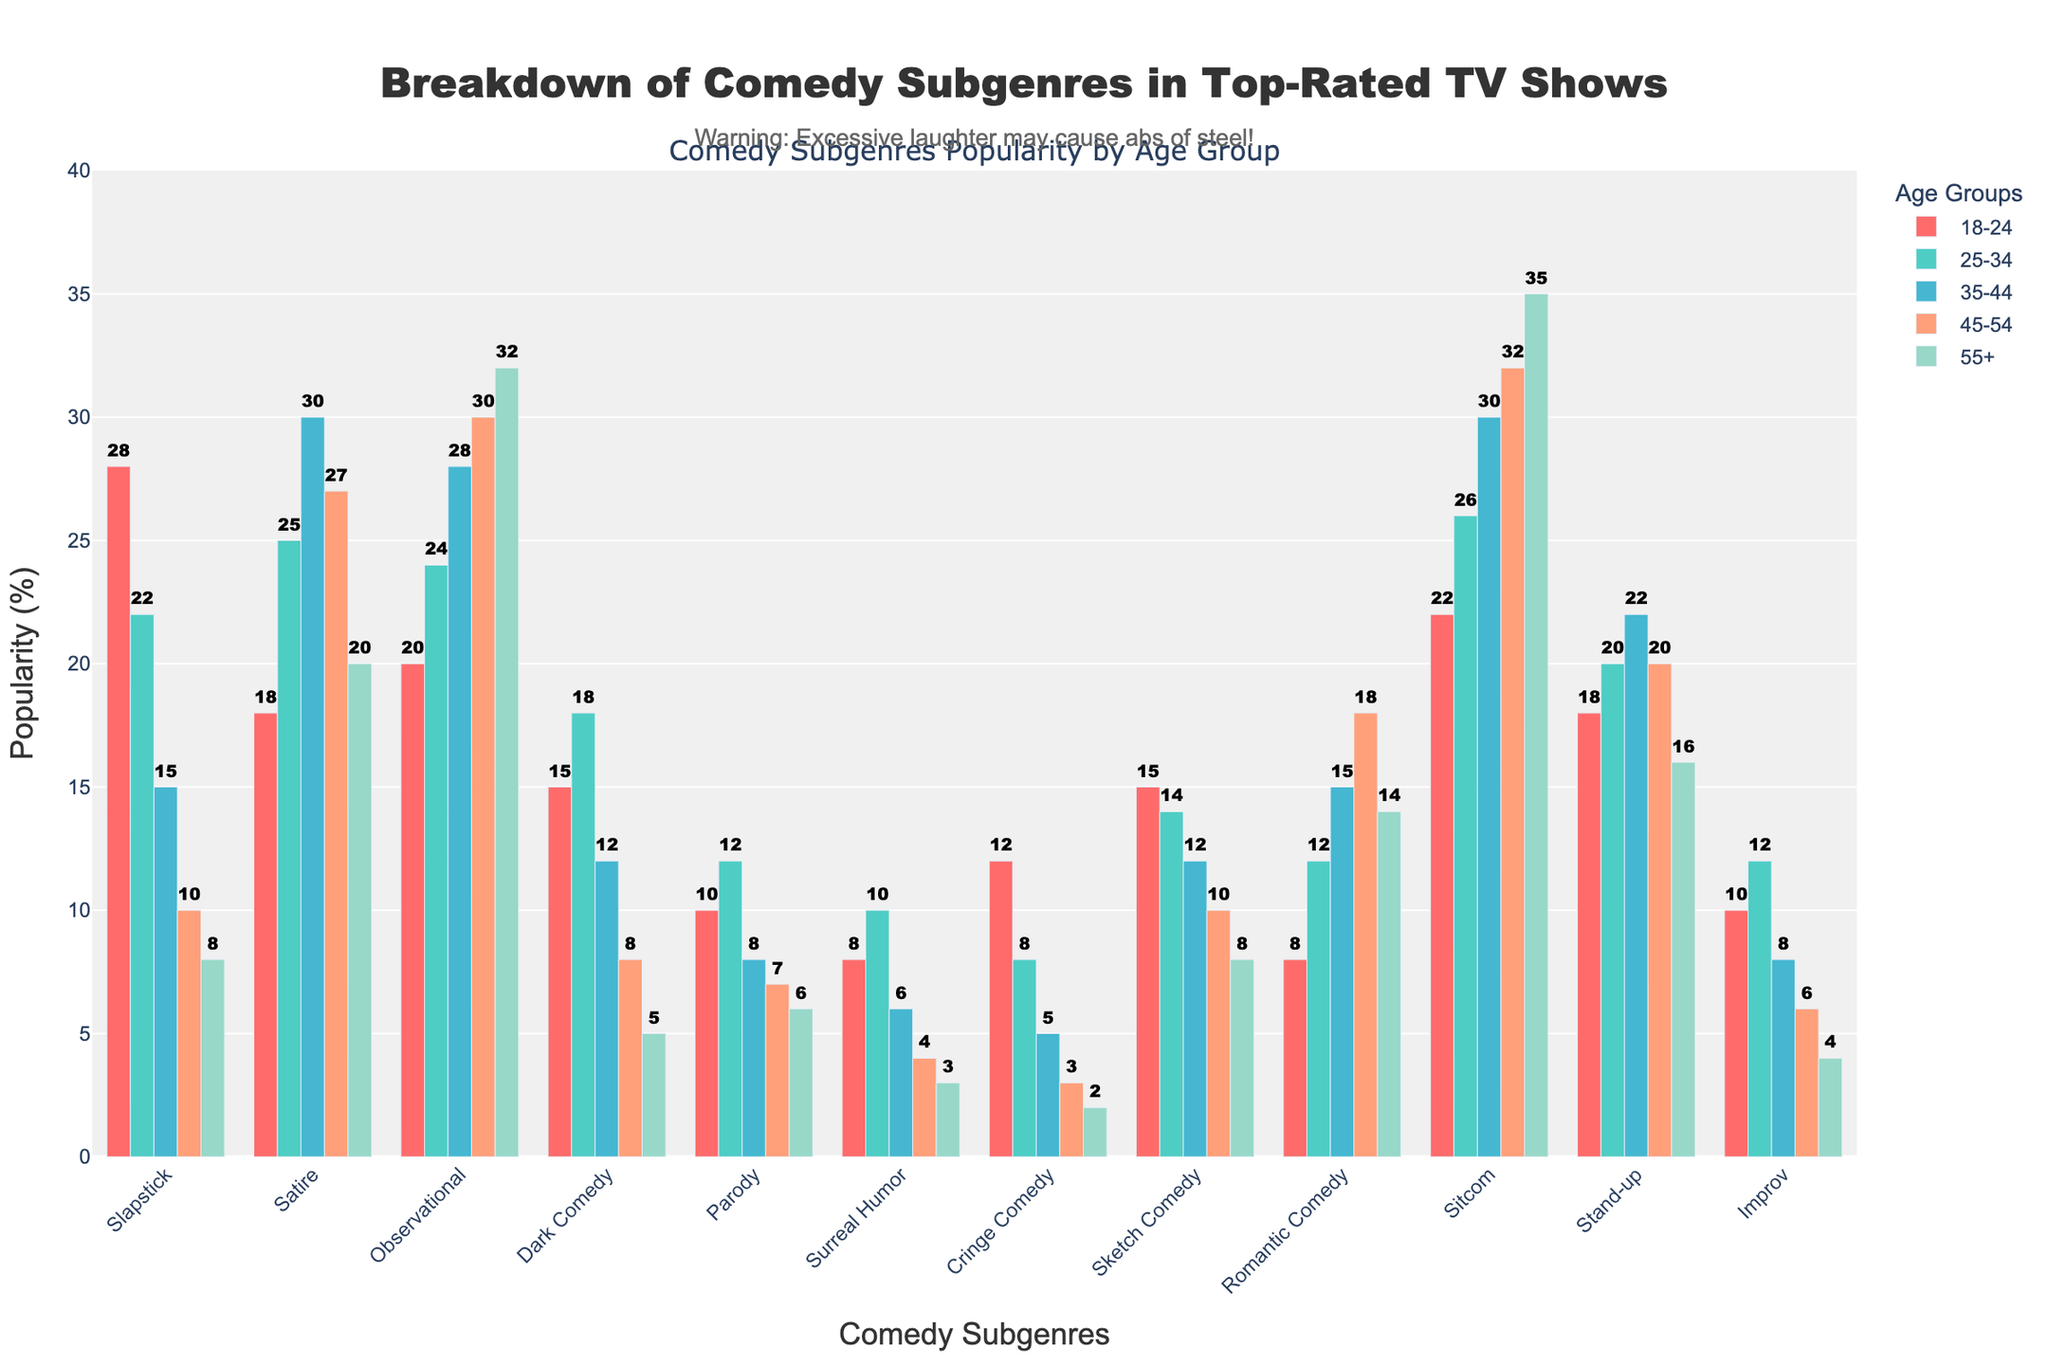Which comedy subgenre is the most popular among viewers aged 18-24? By examining the bar chart, we identify that the subgenre "Slapstick" has the tallest bar among viewers aged 18-24 at 28%.
Answer: Slapstick Which two age groups show the highest popularity for "Sitcom"? From the chart, check the bar heights for "Sitcom" across age groups. The highest values are for 55+ (35%) and 45-54 (32%).
Answer: 55+, 45-54 What is the total popularity percentage of "Observational" comedy across all age groups? Sum the values for "Observational" in all age groups: \(20 + 24 + 28 + 30 + 32 = 134\).
Answer: 134% Which age group shows the least preference for "Cringe Comedy"? By looking at the bars for "Cringe Comedy", the 55+ age group has the smallest bar at 2%.
Answer: 55+ How does the popularity of "Parody" among 25-34-year-olds compare to that among 35-44-year-olds? Comparing the bars for "Parody", 25-34-year-olds have a 12% bar, and 35-44-year-olds have an 8% bar. Thus, 25-34 is higher.
Answer: 25-34 > 35-44 Which subgenre has the lowest popularity among viewers aged 55+? Examine the bars for each subgenre in the 55+ group; "Surreal Humor" is the shortest at 3%.
Answer: Surreal Humor For which subgenre is the distribution across age groups the most balanced? Reviewing the chart, "Stand-up" appears most balanced, with percentages ranging between 16-22% across all age groups.
Answer: Stand-up What is the difference in popularity of "Dark Comedy" between the youngest (18-24) and oldest (55+) age groups? Subtract the value for 55+ (5%) from the value for 18-24 (15%): \(15% - 5% = 10%\).
Answer: 10% What is the combined popularity percentage of "Slapstick" and "Sitcom" among viewers aged 35-44? Add the values for "Slapstick" (15%) and "Sitcom" (30%) for the 35-44 age group: \(15% + 30% = 45%\).
Answer: 45% Which age group shows the highest preference for "Romantic Comedy"? Identify the tallest bar for "Romantic Comedy", which is at 18% for 45-54-year-olds.
Answer: 45-54 